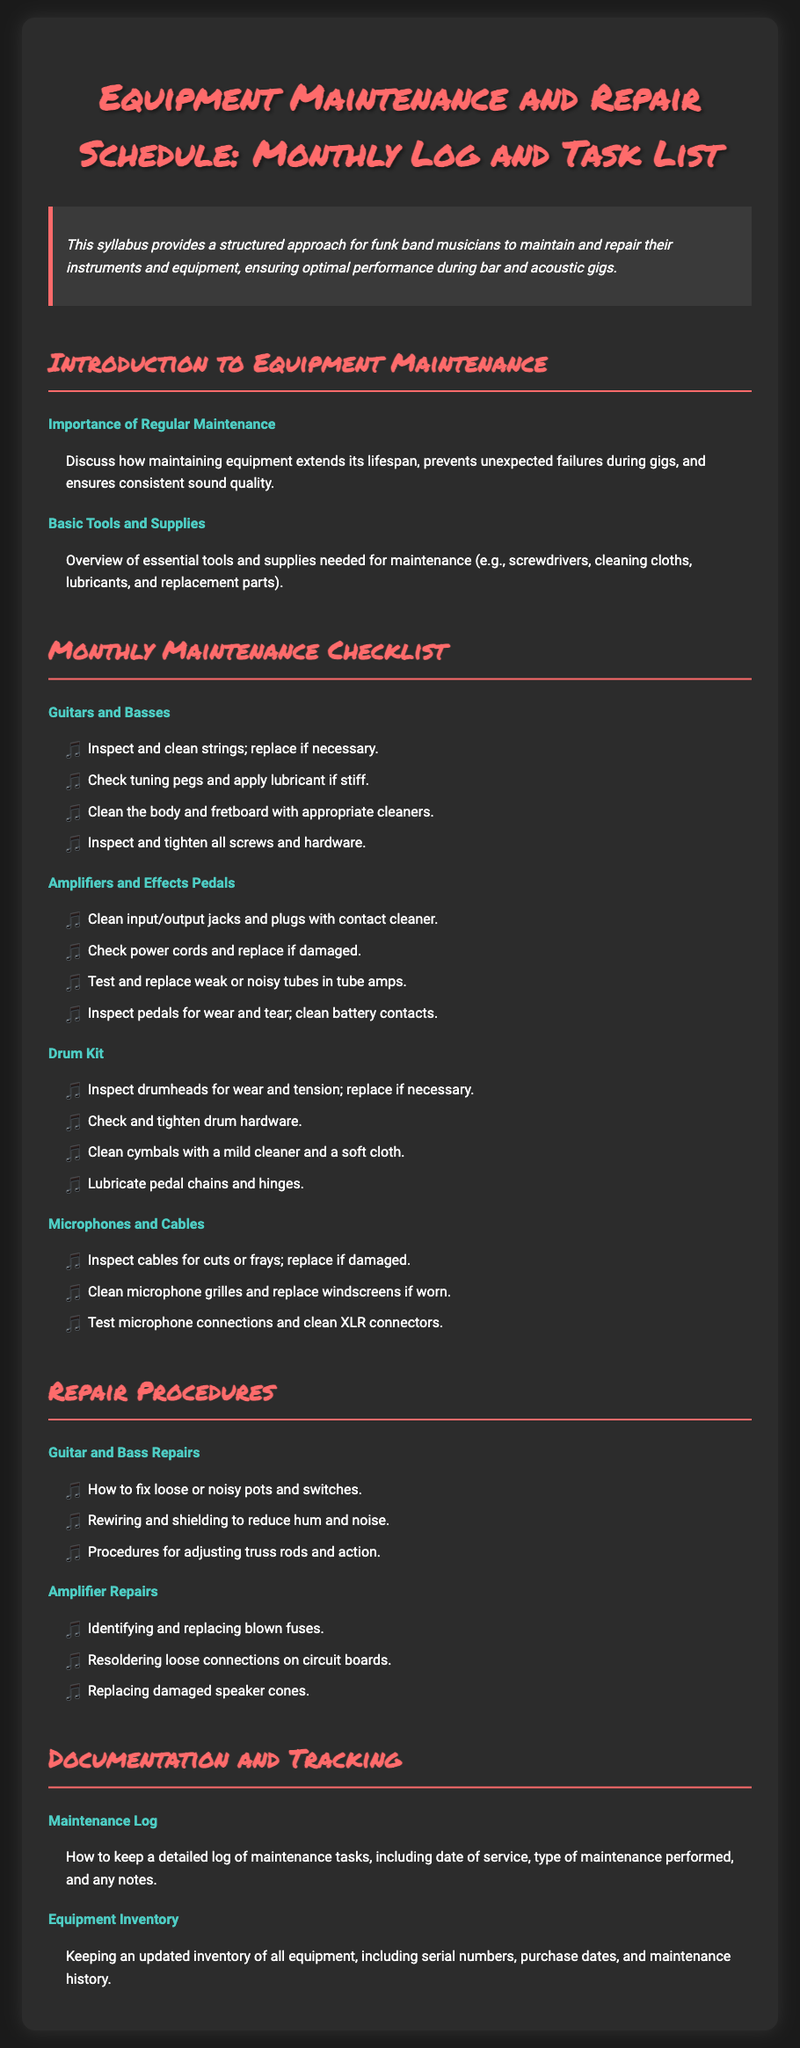what is the title of the document? The title of the document is presented prominently at the top of the syllabus.
Answer: Equipment Maintenance and Repair Schedule: Monthly Log and Task List what are essential tools mentioned for maintenance? The syllabus provides an overview of tools that are important for instrument maintenance.
Answer: screwdrivers, cleaning cloths, lubricants, replacement parts how many topics are listed under "Monthly Maintenance Checklist"? The syllabus includes several sections and topics under the checklist heading.
Answer: four what is one of the inspection tasks for drum kits? The document specifies tasks to be performed on drum kits under the maintenance checklist.
Answer: Inspect drumheads for wear and tension what is one repair procedure for amplifiers? The syllabus explains procedures for various repairs, including those specific to amplifiers.
Answer: Identifying and replacing blown fuses what must be included in the maintenance log? The document describes details that should be recorded in the maintenance log.
Answer: date of service, type of maintenance performed, notes how often should equipment maintenance be performed according to the syllabus? The syllabus is structured around a monthly schedule for maintenance tasks.
Answer: monthly what specific type of equipment does the syllabus focus on? The syllabus outlines how to maintain various types of musical equipment relevant to musicians.
Answer: instruments and equipment 